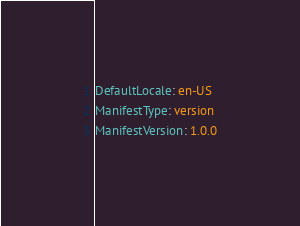<code> <loc_0><loc_0><loc_500><loc_500><_YAML_>DefaultLocale: en-US
ManifestType: version
ManifestVersion: 1.0.0
</code> 